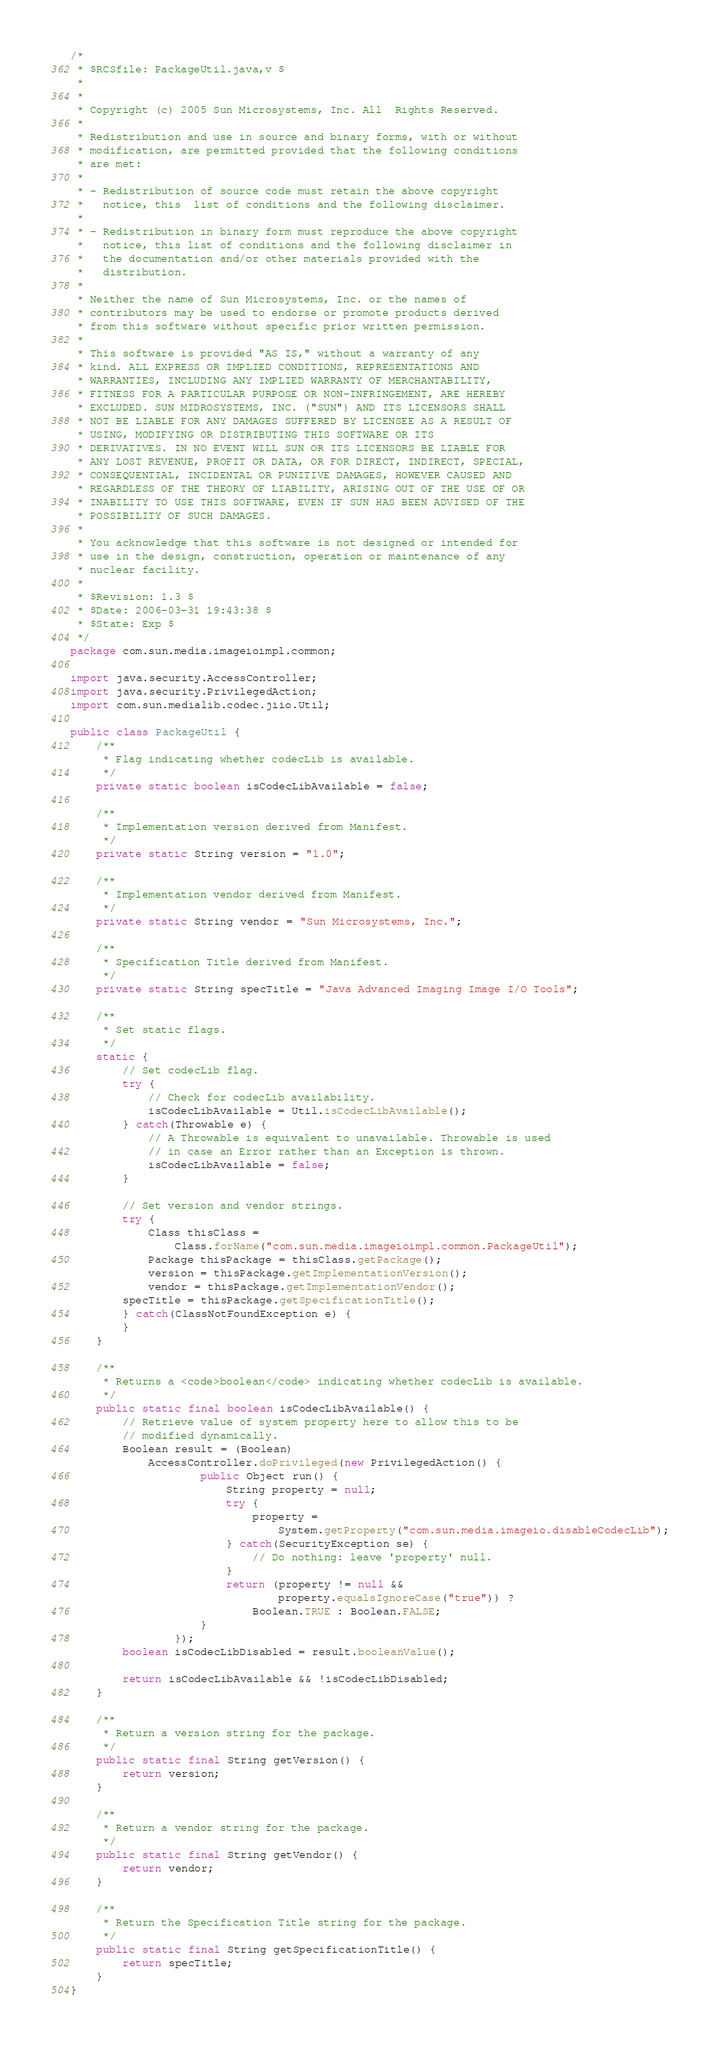Convert code to text. <code><loc_0><loc_0><loc_500><loc_500><_Java_>/*
 * $RCSfile: PackageUtil.java,v $
 *
 * 
 * Copyright (c) 2005 Sun Microsystems, Inc. All  Rights Reserved.
 * 
 * Redistribution and use in source and binary forms, with or without
 * modification, are permitted provided that the following conditions
 * are met: 
 * 
 * - Redistribution of source code must retain the above copyright 
 *   notice, this  list of conditions and the following disclaimer.
 * 
 * - Redistribution in binary form must reproduce the above copyright
 *   notice, this list of conditions and the following disclaimer in 
 *   the documentation and/or other materials provided with the
 *   distribution.
 * 
 * Neither the name of Sun Microsystems, Inc. or the names of 
 * contributors may be used to endorse or promote products derived 
 * from this software without specific prior written permission.
 * 
 * This software is provided "AS IS," without a warranty of any 
 * kind. ALL EXPRESS OR IMPLIED CONDITIONS, REPRESENTATIONS AND 
 * WARRANTIES, INCLUDING ANY IMPLIED WARRANTY OF MERCHANTABILITY, 
 * FITNESS FOR A PARTICULAR PURPOSE OR NON-INFRINGEMENT, ARE HEREBY
 * EXCLUDED. SUN MIDROSYSTEMS, INC. ("SUN") AND ITS LICENSORS SHALL 
 * NOT BE LIABLE FOR ANY DAMAGES SUFFERED BY LICENSEE AS A RESULT OF 
 * USING, MODIFYING OR DISTRIBUTING THIS SOFTWARE OR ITS
 * DERIVATIVES. IN NO EVENT WILL SUN OR ITS LICENSORS BE LIABLE FOR 
 * ANY LOST REVENUE, PROFIT OR DATA, OR FOR DIRECT, INDIRECT, SPECIAL,
 * CONSEQUENTIAL, INCIDENTAL OR PUNITIVE DAMAGES, HOWEVER CAUSED AND
 * REGARDLESS OF THE THEORY OF LIABILITY, ARISING OUT OF THE USE OF OR
 * INABILITY TO USE THIS SOFTWARE, EVEN IF SUN HAS BEEN ADVISED OF THE
 * POSSIBILITY OF SUCH DAMAGES. 
 * 
 * You acknowledge that this software is not designed or intended for 
 * use in the design, construction, operation or maintenance of any 
 * nuclear facility. 
 *
 * $Revision: 1.3 $
 * $Date: 2006-03-31 19:43:38 $
 * $State: Exp $
 */
package com.sun.media.imageioimpl.common;

import java.security.AccessController;
import java.security.PrivilegedAction;
import com.sun.medialib.codec.jiio.Util;

public class PackageUtil {
    /**
     * Flag indicating whether codecLib is available.
     */
    private static boolean isCodecLibAvailable = false;

    /**
     * Implementation version derived from Manifest.
     */
    private static String version = "1.0";

    /**
     * Implementation vendor derived from Manifest.
     */
    private static String vendor = "Sun Microsystems, Inc.";

    /**
     * Specification Title derived from Manifest.
     */
    private static String specTitle = "Java Advanced Imaging Image I/O Tools";

    /**
     * Set static flags.
     */
    static {
        // Set codecLib flag.
        try {
            // Check for codecLib availability.
            isCodecLibAvailable = Util.isCodecLibAvailable();
        } catch(Throwable e) {
            // A Throwable is equivalent to unavailable. Throwable is used
            // in case an Error rather than an Exception is thrown.
            isCodecLibAvailable = false;
        }

        // Set version and vendor strings.
        try {
            Class thisClass =
                Class.forName("com.sun.media.imageioimpl.common.PackageUtil");
            Package thisPackage = thisClass.getPackage();
            version = thisPackage.getImplementationVersion();
            vendor = thisPackage.getImplementationVendor();
	    specTitle = thisPackage.getSpecificationTitle();
        } catch(ClassNotFoundException e) {
        }
    }

    /**
     * Returns a <code>boolean</code> indicating whether codecLib is available.
     */
    public static final boolean isCodecLibAvailable() {
        // Retrieve value of system property here to allow this to be
        // modified dynamically.
        Boolean result = (Boolean)
            AccessController.doPrivileged(new PrivilegedAction() {
                    public Object run() {
                        String property = null;
                        try {
                            property =
                                System.getProperty("com.sun.media.imageio.disableCodecLib");
                        } catch(SecurityException se) {
                            // Do nothing: leave 'property' null.
                        }
                        return (property != null &&
                                property.equalsIgnoreCase("true")) ?
                            Boolean.TRUE : Boolean.FALSE;
                    }
                });
        boolean isCodecLibDisabled = result.booleanValue();

        return isCodecLibAvailable && !isCodecLibDisabled;
    }

    /**
     * Return a version string for the package.
     */
    public static final String getVersion() {
        return version;
    }

    /**
     * Return a vendor string for the package.
     */
    public static final String getVendor() {
        return vendor;
    }

    /**
     * Return the Specification Title string for the package.
     */
    public static final String getSpecificationTitle() {
        return specTitle;
    }
}
</code> 